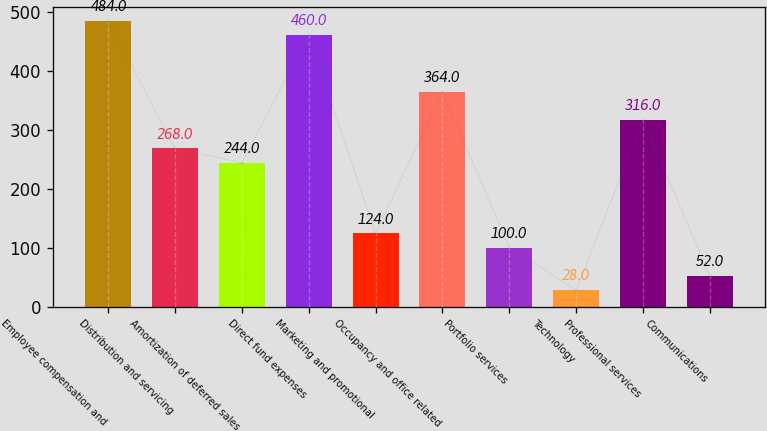<chart> <loc_0><loc_0><loc_500><loc_500><bar_chart><fcel>Employee compensation and<fcel>Distribution and servicing<fcel>Amortization of deferred sales<fcel>Direct fund expenses<fcel>Marketing and promotional<fcel>Occupancy and office related<fcel>Portfolio services<fcel>Technology<fcel>Professional services<fcel>Communications<nl><fcel>484<fcel>268<fcel>244<fcel>460<fcel>124<fcel>364<fcel>100<fcel>28<fcel>316<fcel>52<nl></chart> 